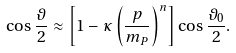<formula> <loc_0><loc_0><loc_500><loc_500>\cos \frac { \vartheta } { 2 } \approx \left [ 1 - \kappa \left ( \frac { p } { m _ { P } } \right ) ^ { n } \right ] \cos \frac { \vartheta _ { 0 } } { 2 } .</formula> 